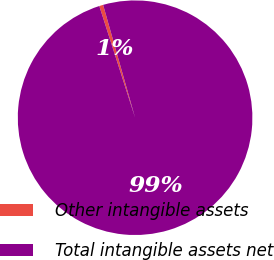<chart> <loc_0><loc_0><loc_500><loc_500><pie_chart><fcel>Other intangible assets<fcel>Total intangible assets net<nl><fcel>0.54%<fcel>99.46%<nl></chart> 